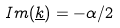Convert formula to latex. <formula><loc_0><loc_0><loc_500><loc_500>I m ( \underline { k } ) = - \alpha / 2</formula> 